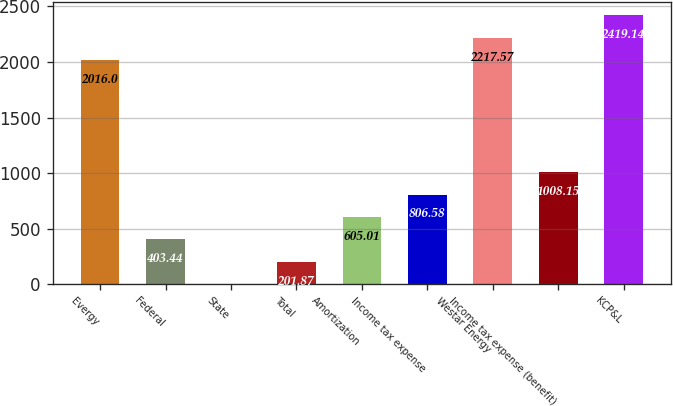Convert chart to OTSL. <chart><loc_0><loc_0><loc_500><loc_500><bar_chart><fcel>Evergy<fcel>Federal<fcel>State<fcel>Total<fcel>Amortization<fcel>Income tax expense<fcel>Westar Energy<fcel>Income tax expense (benefit)<fcel>KCP&L<nl><fcel>2016<fcel>403.44<fcel>0.3<fcel>201.87<fcel>605.01<fcel>806.58<fcel>2217.57<fcel>1008.15<fcel>2419.14<nl></chart> 